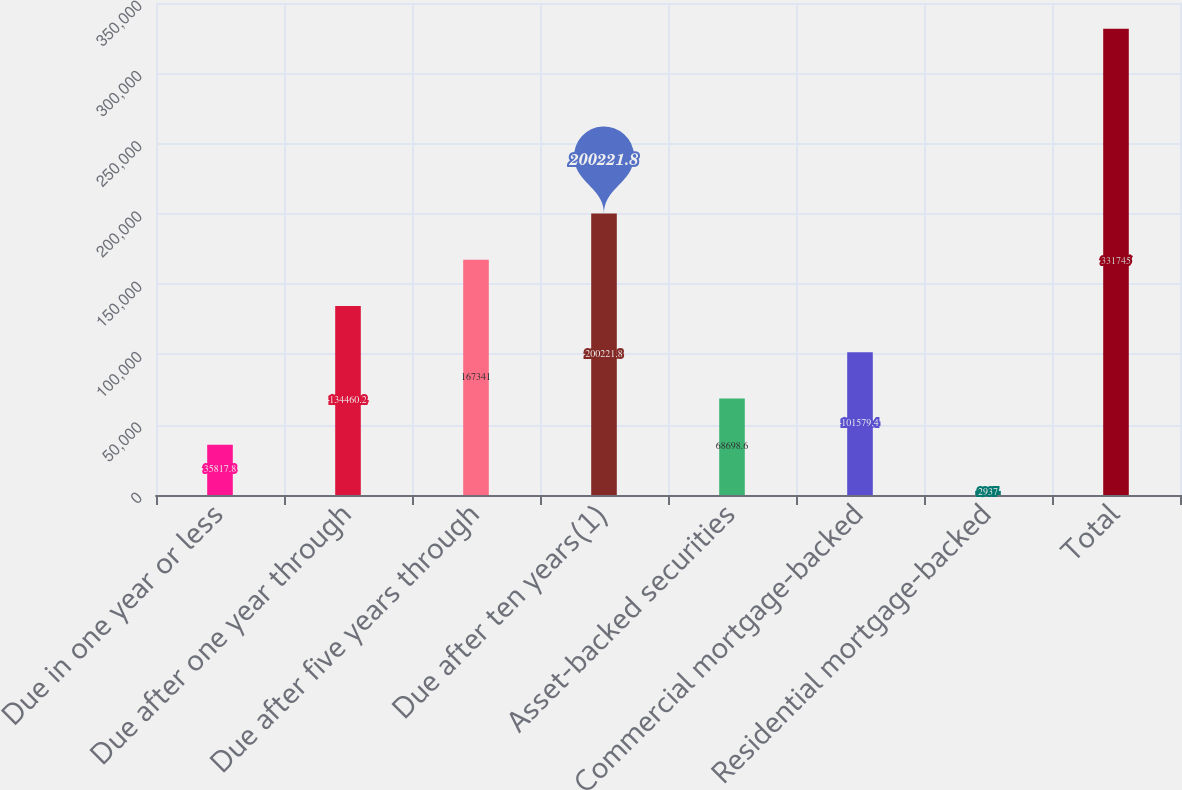Convert chart to OTSL. <chart><loc_0><loc_0><loc_500><loc_500><bar_chart><fcel>Due in one year or less<fcel>Due after one year through<fcel>Due after five years through<fcel>Due after ten years(1)<fcel>Asset-backed securities<fcel>Commercial mortgage-backed<fcel>Residential mortgage-backed<fcel>Total<nl><fcel>35817.8<fcel>134460<fcel>167341<fcel>200222<fcel>68698.6<fcel>101579<fcel>2937<fcel>331745<nl></chart> 